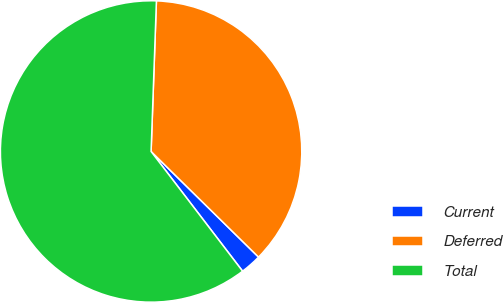<chart> <loc_0><loc_0><loc_500><loc_500><pie_chart><fcel>Current<fcel>Deferred<fcel>Total<nl><fcel>2.25%<fcel>36.8%<fcel>60.95%<nl></chart> 